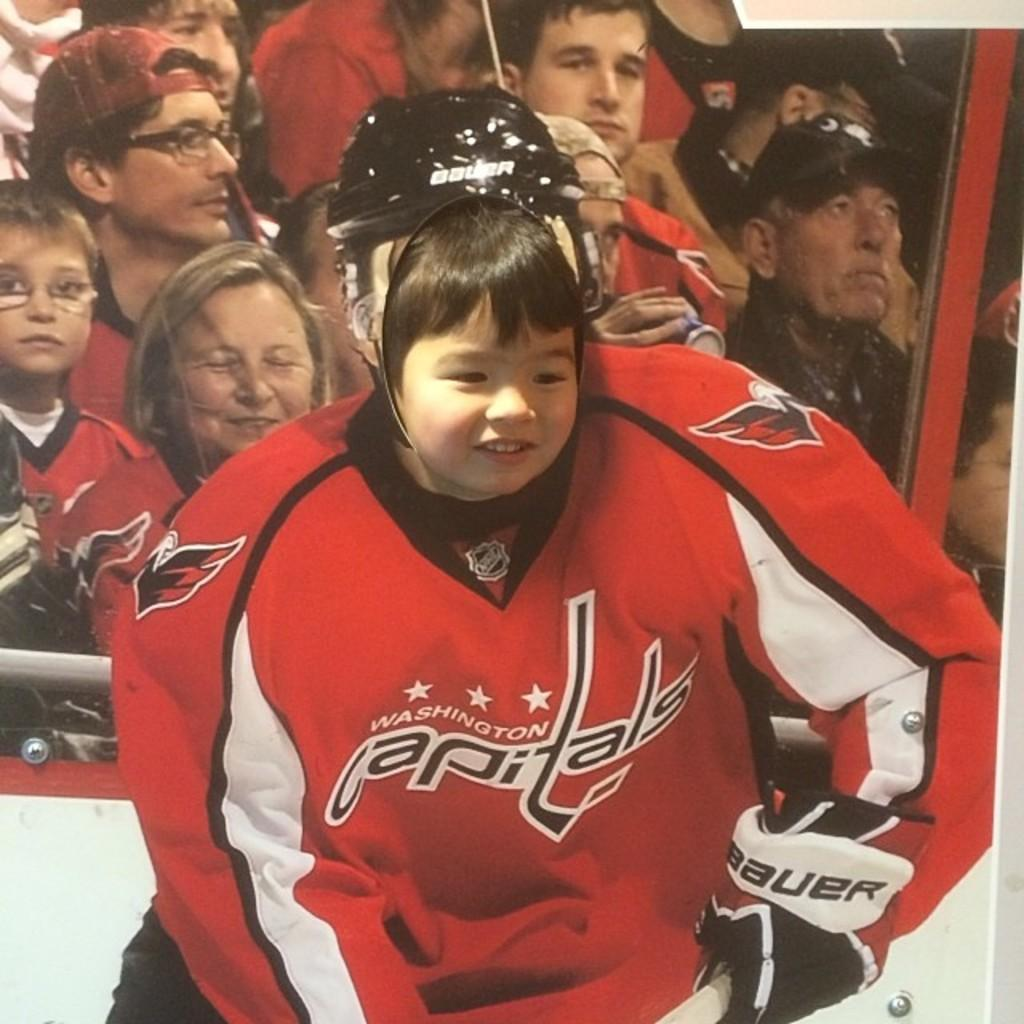<image>
Summarize the visual content of the image. A child takes a picture using a Washington Capitals jersey cut-out. 